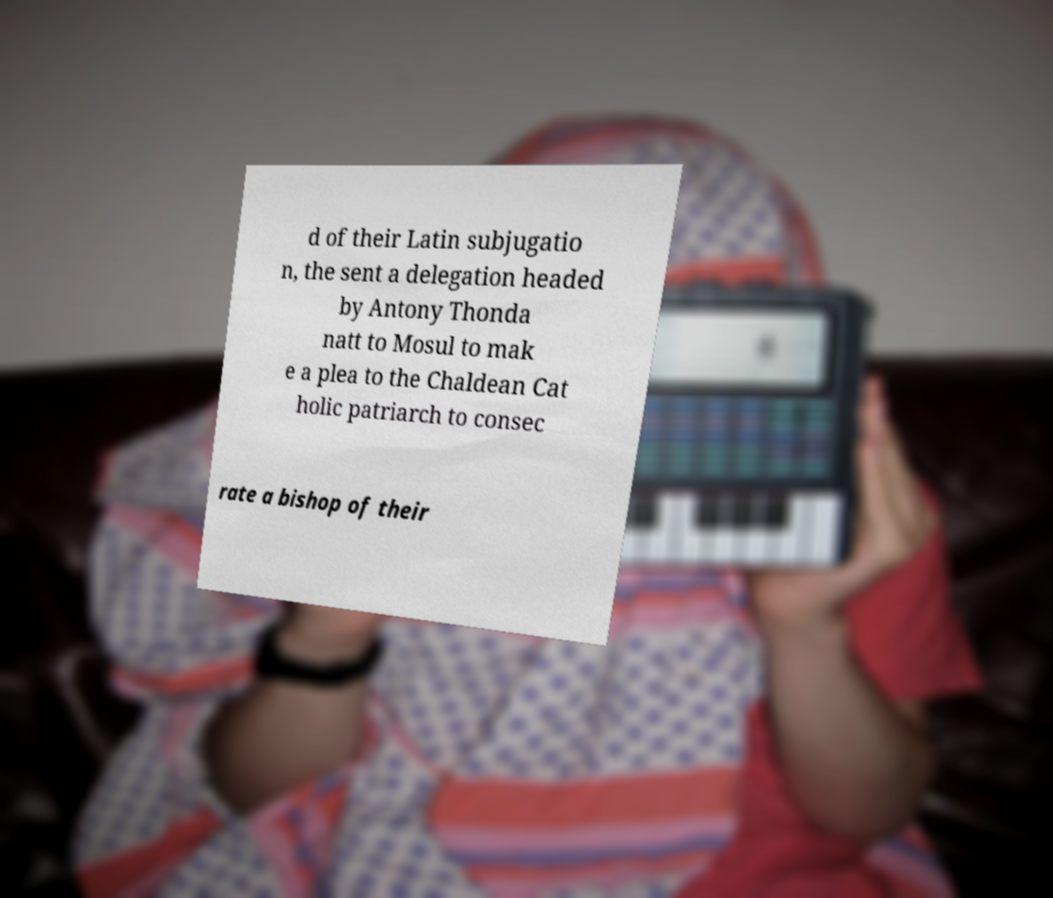Can you accurately transcribe the text from the provided image for me? d of their Latin subjugatio n, the sent a delegation headed by Antony Thonda natt to Mosul to mak e a plea to the Chaldean Cat holic patriarch to consec rate a bishop of their 